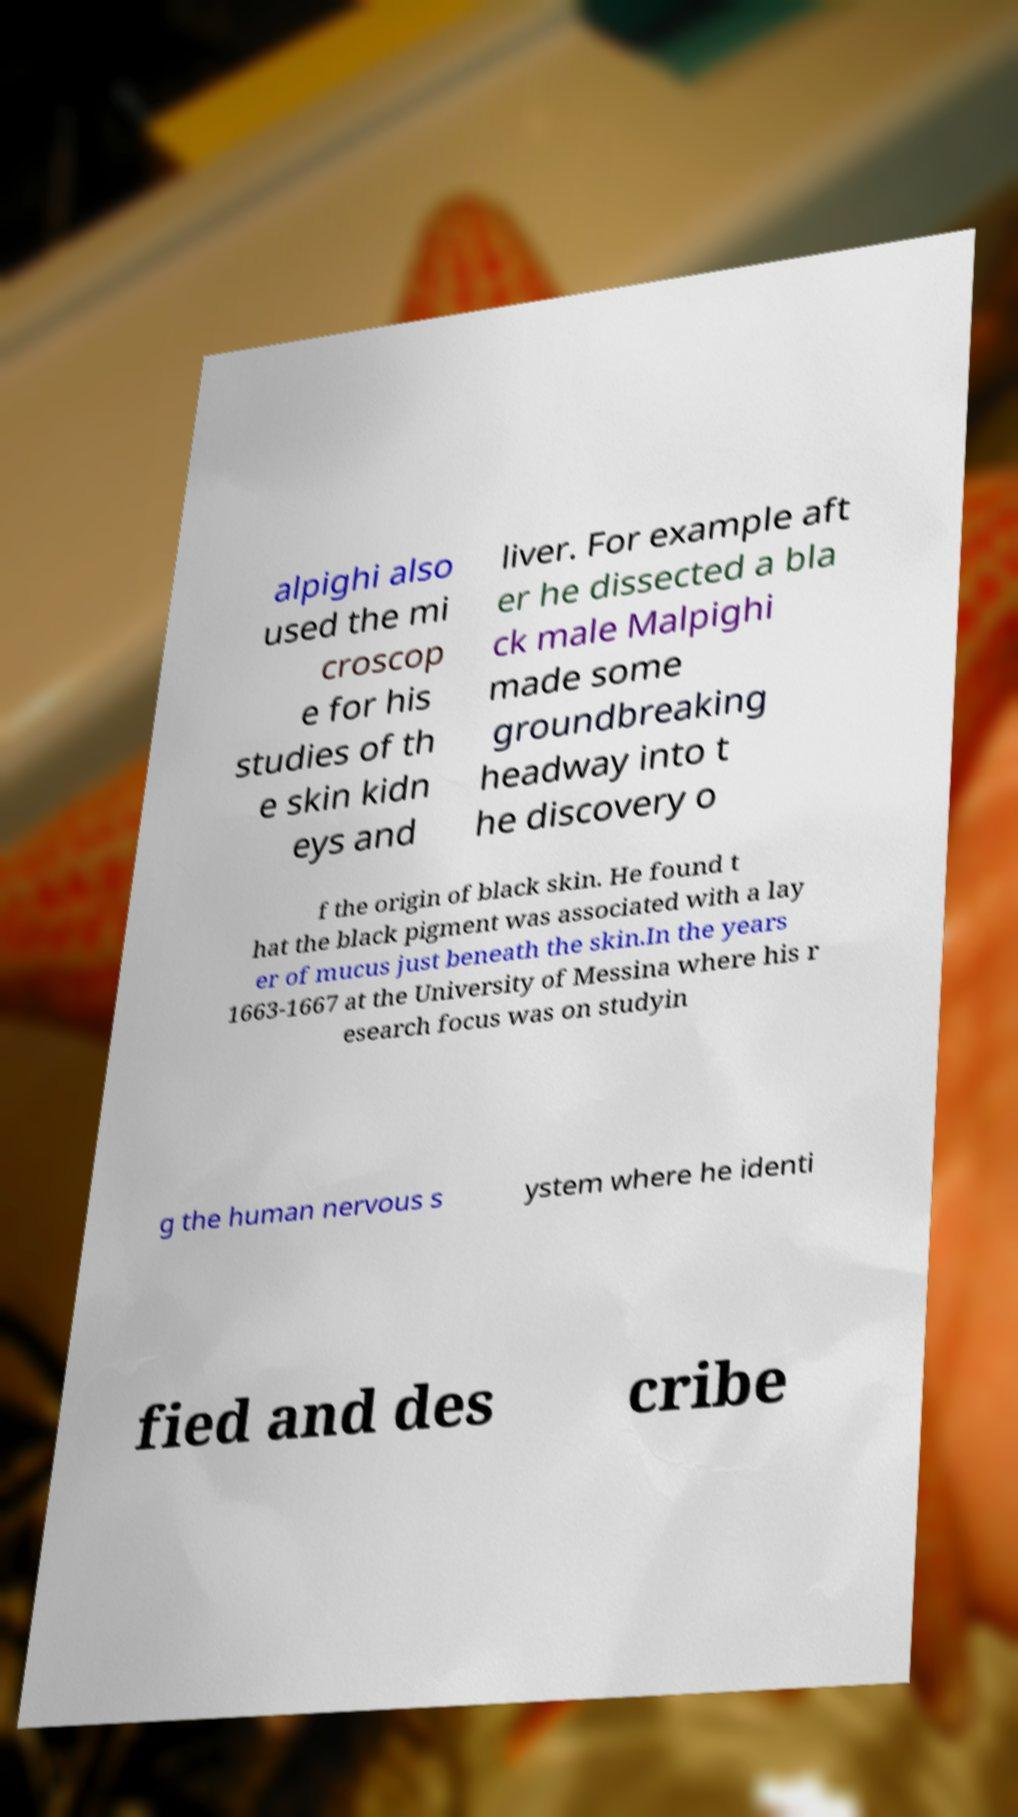Please identify and transcribe the text found in this image. alpighi also used the mi croscop e for his studies of th e skin kidn eys and liver. For example aft er he dissected a bla ck male Malpighi made some groundbreaking headway into t he discovery o f the origin of black skin. He found t hat the black pigment was associated with a lay er of mucus just beneath the skin.In the years 1663-1667 at the University of Messina where his r esearch focus was on studyin g the human nervous s ystem where he identi fied and des cribe 